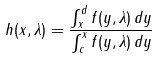<formula> <loc_0><loc_0><loc_500><loc_500>h ( x , \lambda ) = \frac { \int _ { x } ^ { d } f ( y , \lambda ) \, d y } { \int _ { c } ^ { x } f ( y , \lambda ) \, d y }</formula> 